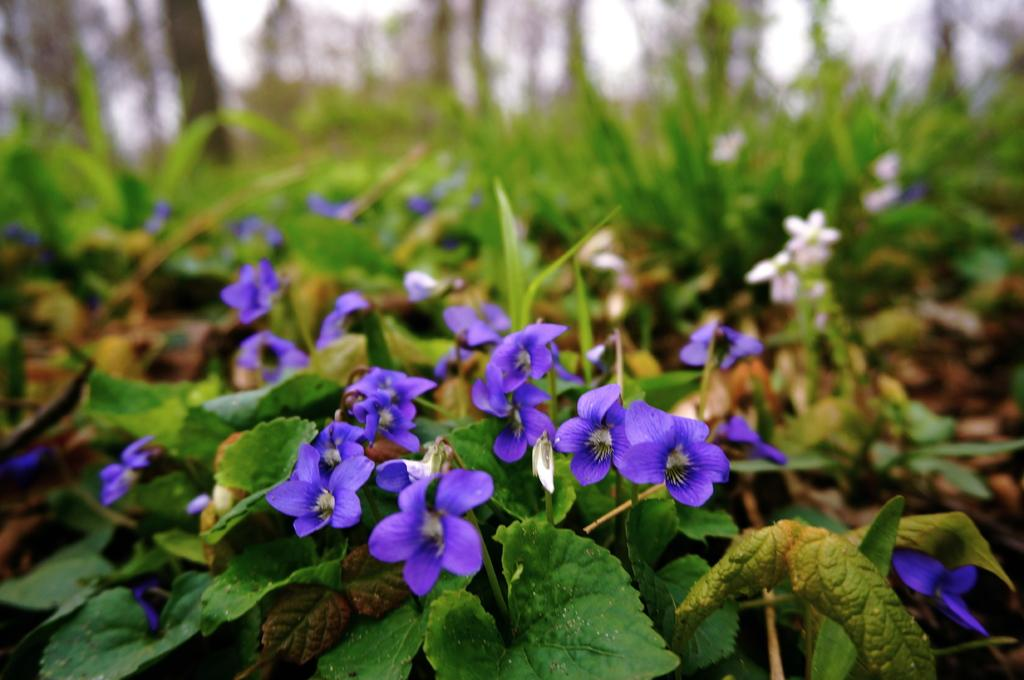What type of living organisms can be seen in the image? Plants and trees are visible in the image. What color are the flowers on the plants in the image? There are purple flowers in the image. What else can be seen in the image besides plants and flowers? The sky is visible in the image. Can you see any feathers on the plants in the image? There are no feathers present on the plants in the image. What type of cork can be seen on the chin of the person in the image? There is no person or cork present in the image; it features plants and flowers. 